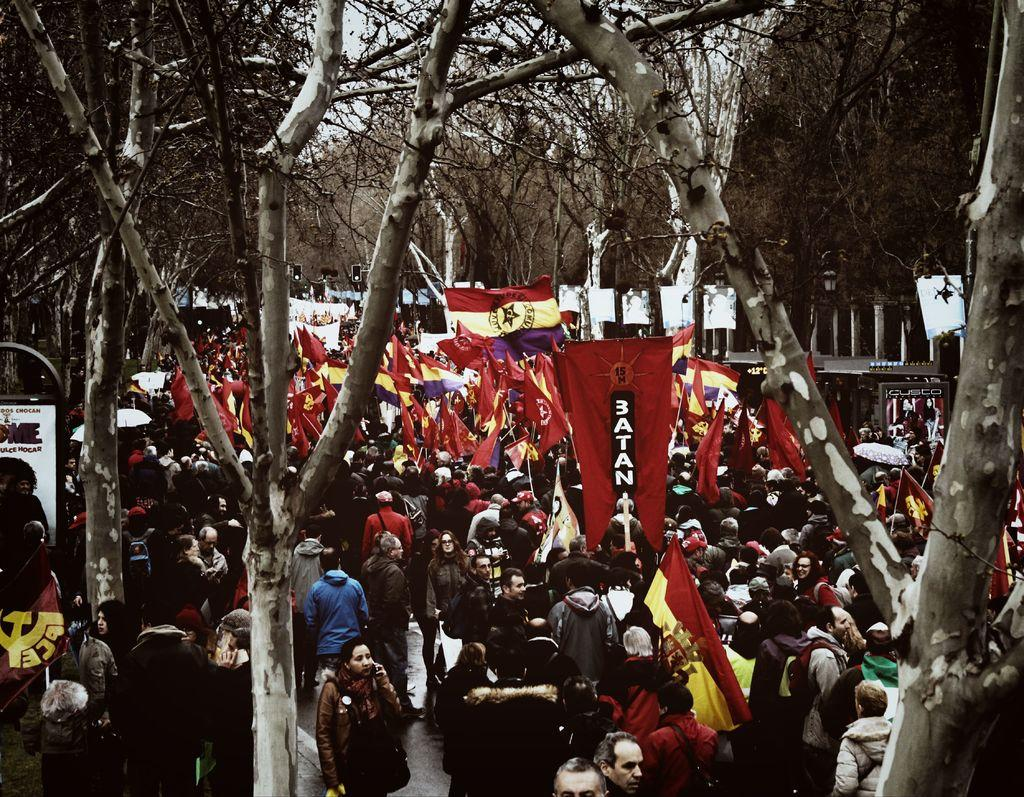What are the people in the image doing? There is a group of people standing on the road in the image. What can be seen hanging or displayed in the image? Banners and flags are present in the image. What type of transportation is visible in the image? There is a vehicle in the image. What helps control traffic in the image? Traffic signal lights are present in the image. What type of vegetation can be seen in the image? Trees are visible in the image. What are some unidentified objects in the image? There are some unspecified objects in the image. What can be seen in the background of the image? The sky is visible in the background of the image. Where is the map located in the image? There is no map present in the image. What type of pan is being used by the people in the image? There is no pan visible in the image; the people are standing on the road. 